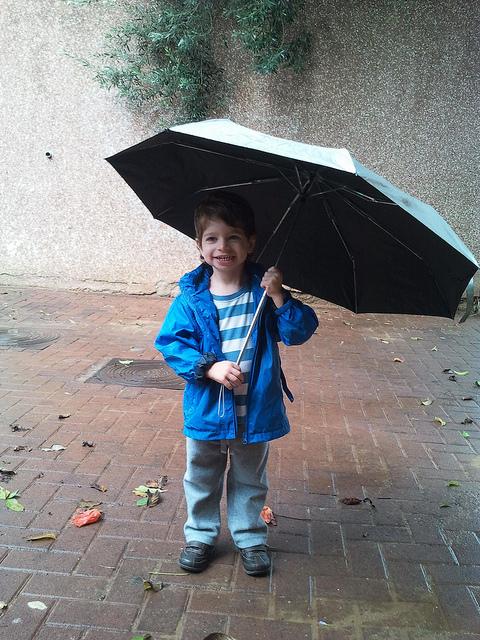Is the umbrella keeping the boy dry?
Short answer required. Yes. Is it raining?
Quick response, please. No. Is the boy happy?
Keep it brief. Yes. 